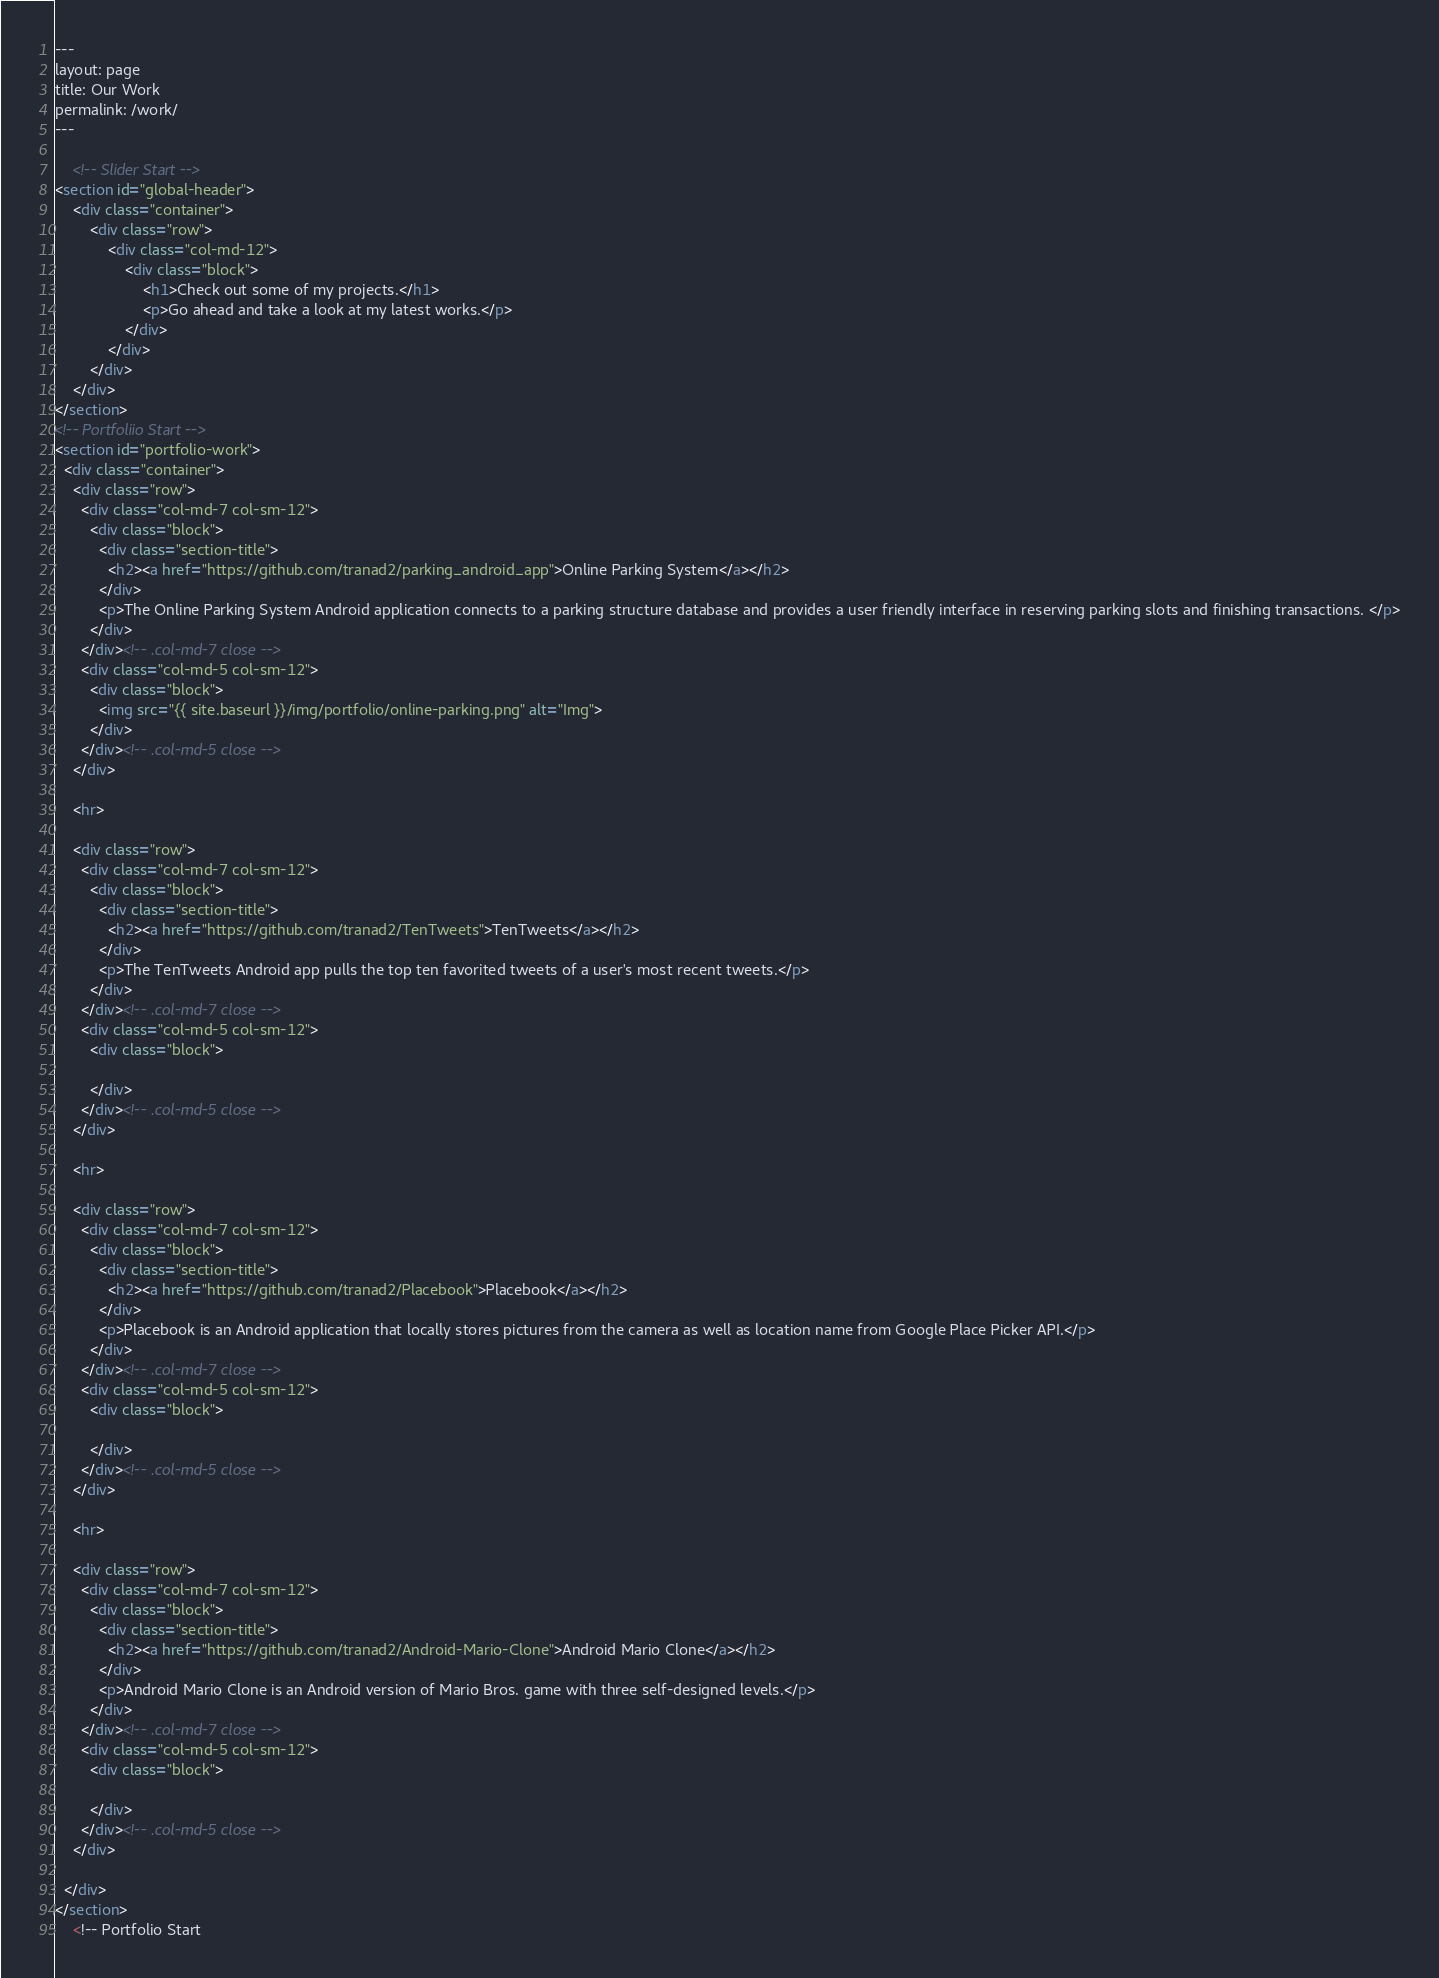Convert code to text. <code><loc_0><loc_0><loc_500><loc_500><_HTML_>---
layout: page
title: Our Work
permalink: /work/
---

    <!-- Slider Start -->
<section id="global-header">
    <div class="container">
        <div class="row">
            <div class="col-md-12">
                <div class="block">
                    <h1>Check out some of my projects.</h1>
                    <p>Go ahead and take a look at my latest works.</p>
                </div>
            </div>
        </div>
    </div>
</section>
<!-- Portfoliio Start -->
<section id="portfolio-work">
  <div class="container">
    <div class="row">
      <div class="col-md-7 col-sm-12">
        <div class="block">
          <div class="section-title">
            <h2><a href="https://github.com/tranad2/parking_android_app">Online Parking System</a></h2>
          </div>
          <p>The Online Parking System Android application connects to a parking structure database and provides a user friendly interface in reserving parking slots and finishing transactions. </p>
        </div>
      </div><!-- .col-md-7 close -->
      <div class="col-md-5 col-sm-12">
        <div class="block">
          <img src="{{ site.baseurl }}/img/portfolio/online-parking.png" alt="Img">
        </div>
      </div><!-- .col-md-5 close -->
    </div>

    <hr>

    <div class="row">
      <div class="col-md-7 col-sm-12">
        <div class="block">
          <div class="section-title">
            <h2><a href="https://github.com/tranad2/TenTweets">TenTweets</a></h2>
          </div>
          <p>The TenTweets Android app pulls the top ten favorited tweets of a user's most recent tweets.</p>
        </div>
      </div><!-- .col-md-7 close -->
      <div class="col-md-5 col-sm-12">
        <div class="block">

        </div>
      </div><!-- .col-md-5 close -->
    </div>

    <hr>

    <div class="row">
      <div class="col-md-7 col-sm-12">
        <div class="block">
          <div class="section-title">
            <h2><a href="https://github.com/tranad2/Placebook">Placebook</a></h2>
          </div>
          <p>Placebook is an Android application that locally stores pictures from the camera as well as location name from Google Place Picker API.</p>
        </div>
      </div><!-- .col-md-7 close -->
      <div class="col-md-5 col-sm-12">
        <div class="block">

        </div>
      </div><!-- .col-md-5 close -->
    </div>

    <hr>

    <div class="row">
      <div class="col-md-7 col-sm-12">
        <div class="block">
          <div class="section-title">
            <h2><a href="https://github.com/tranad2/Android-Mario-Clone">Android Mario Clone</a></h2>
          </div>
          <p>Android Mario Clone is an Android version of Mario Bros. game with three self-designed levels.</p>
        </div>
      </div><!-- .col-md-7 close -->
      <div class="col-md-5 col-sm-12">
        <div class="block">

        </div>
      </div><!-- .col-md-5 close -->
    </div>

  </div>
</section>
    <!-- Portfolio Start</code> 